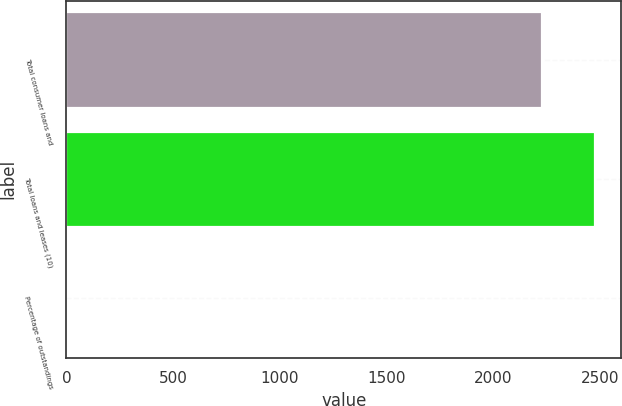Convert chart to OTSL. <chart><loc_0><loc_0><loc_500><loc_500><bar_chart><fcel>Total consumer loans and<fcel>Total loans and leases (10)<fcel>Percentage of outstandings<nl><fcel>2230<fcel>2475.97<fcel>0.27<nl></chart> 